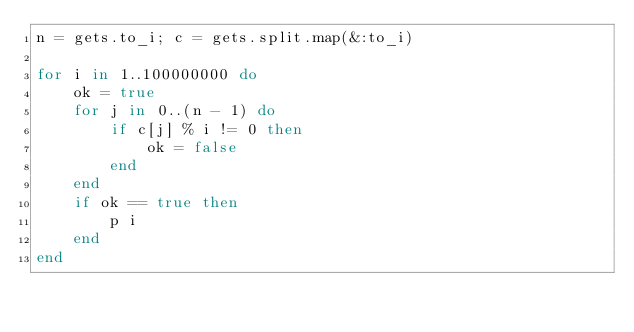<code> <loc_0><loc_0><loc_500><loc_500><_Ruby_>n = gets.to_i; c = gets.split.map(&:to_i)
 
for i in 1..100000000 do
    ok = true
    for j in 0..(n - 1) do
        if c[j] % i != 0 then
            ok = false
        end
    end
    if ok == true then
        p i
    end
end</code> 